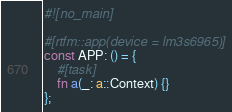<code> <loc_0><loc_0><loc_500><loc_500><_Rust_>#![no_main]

#[rtfm::app(device = lm3s6965)]
const APP: () = {
    #[task]
    fn a(_: a::Context) {}
};
</code> 